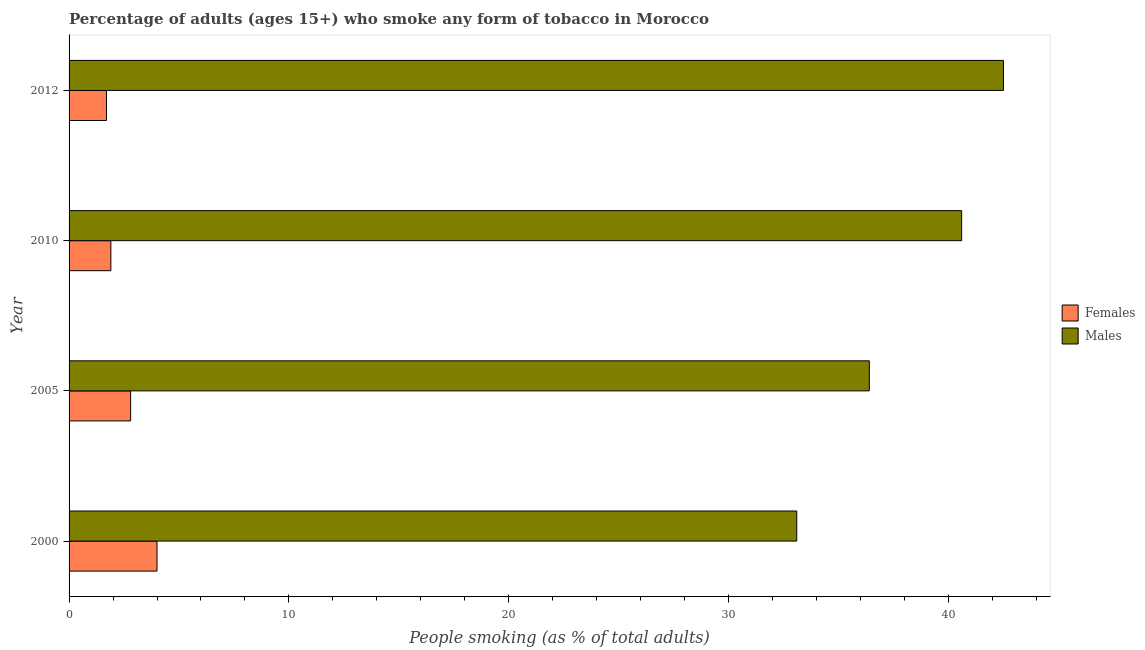How many different coloured bars are there?
Make the answer very short. 2. How many groups of bars are there?
Provide a succinct answer. 4. Are the number of bars on each tick of the Y-axis equal?
Give a very brief answer. Yes. How many bars are there on the 1st tick from the bottom?
Give a very brief answer. 2. What is the percentage of males who smoke in 2000?
Offer a terse response. 33.1. Across all years, what is the maximum percentage of males who smoke?
Provide a succinct answer. 42.5. Across all years, what is the minimum percentage of males who smoke?
Offer a terse response. 33.1. In which year was the percentage of females who smoke minimum?
Provide a succinct answer. 2012. What is the total percentage of males who smoke in the graph?
Offer a terse response. 152.6. What is the difference between the percentage of males who smoke in 2000 and the percentage of females who smoke in 2012?
Keep it short and to the point. 31.4. What is the average percentage of males who smoke per year?
Make the answer very short. 38.15. In the year 2012, what is the difference between the percentage of males who smoke and percentage of females who smoke?
Ensure brevity in your answer.  40.8. What is the ratio of the percentage of females who smoke in 2000 to that in 2012?
Make the answer very short. 2.35. Is the percentage of females who smoke in 2005 less than that in 2012?
Offer a terse response. No. Is the difference between the percentage of males who smoke in 2000 and 2005 greater than the difference between the percentage of females who smoke in 2000 and 2005?
Offer a very short reply. No. What is the difference between the highest and the second highest percentage of females who smoke?
Your response must be concise. 1.2. Is the sum of the percentage of males who smoke in 2005 and 2010 greater than the maximum percentage of females who smoke across all years?
Your answer should be compact. Yes. What does the 2nd bar from the top in 2012 represents?
Give a very brief answer. Females. What does the 2nd bar from the bottom in 2005 represents?
Keep it short and to the point. Males. Are all the bars in the graph horizontal?
Your response must be concise. Yes. What is the difference between two consecutive major ticks on the X-axis?
Keep it short and to the point. 10. Are the values on the major ticks of X-axis written in scientific E-notation?
Your answer should be very brief. No. Does the graph contain any zero values?
Provide a succinct answer. No. Does the graph contain grids?
Give a very brief answer. No. Where does the legend appear in the graph?
Make the answer very short. Center right. How are the legend labels stacked?
Ensure brevity in your answer.  Vertical. What is the title of the graph?
Provide a short and direct response. Percentage of adults (ages 15+) who smoke any form of tobacco in Morocco. What is the label or title of the X-axis?
Offer a terse response. People smoking (as % of total adults). What is the People smoking (as % of total adults) of Females in 2000?
Your answer should be compact. 4. What is the People smoking (as % of total adults) in Males in 2000?
Give a very brief answer. 33.1. What is the People smoking (as % of total adults) in Females in 2005?
Make the answer very short. 2.8. What is the People smoking (as % of total adults) in Males in 2005?
Your answer should be very brief. 36.4. What is the People smoking (as % of total adults) in Females in 2010?
Keep it short and to the point. 1.9. What is the People smoking (as % of total adults) of Males in 2010?
Provide a succinct answer. 40.6. What is the People smoking (as % of total adults) in Males in 2012?
Your answer should be very brief. 42.5. Across all years, what is the maximum People smoking (as % of total adults) in Females?
Ensure brevity in your answer.  4. Across all years, what is the maximum People smoking (as % of total adults) of Males?
Offer a terse response. 42.5. Across all years, what is the minimum People smoking (as % of total adults) of Females?
Offer a very short reply. 1.7. Across all years, what is the minimum People smoking (as % of total adults) of Males?
Offer a very short reply. 33.1. What is the total People smoking (as % of total adults) of Males in the graph?
Ensure brevity in your answer.  152.6. What is the difference between the People smoking (as % of total adults) in Females in 2000 and that in 2012?
Offer a terse response. 2.3. What is the difference between the People smoking (as % of total adults) in Males in 2000 and that in 2012?
Offer a terse response. -9.4. What is the difference between the People smoking (as % of total adults) in Females in 2005 and that in 2010?
Your answer should be compact. 0.9. What is the difference between the People smoking (as % of total adults) in Males in 2005 and that in 2010?
Keep it short and to the point. -4.2. What is the difference between the People smoking (as % of total adults) in Females in 2010 and that in 2012?
Offer a terse response. 0.2. What is the difference between the People smoking (as % of total adults) of Females in 2000 and the People smoking (as % of total adults) of Males in 2005?
Your answer should be very brief. -32.4. What is the difference between the People smoking (as % of total adults) of Females in 2000 and the People smoking (as % of total adults) of Males in 2010?
Offer a terse response. -36.6. What is the difference between the People smoking (as % of total adults) of Females in 2000 and the People smoking (as % of total adults) of Males in 2012?
Offer a terse response. -38.5. What is the difference between the People smoking (as % of total adults) of Females in 2005 and the People smoking (as % of total adults) of Males in 2010?
Your answer should be compact. -37.8. What is the difference between the People smoking (as % of total adults) in Females in 2005 and the People smoking (as % of total adults) in Males in 2012?
Provide a succinct answer. -39.7. What is the difference between the People smoking (as % of total adults) of Females in 2010 and the People smoking (as % of total adults) of Males in 2012?
Your answer should be very brief. -40.6. What is the average People smoking (as % of total adults) of Males per year?
Provide a short and direct response. 38.15. In the year 2000, what is the difference between the People smoking (as % of total adults) of Females and People smoking (as % of total adults) of Males?
Offer a very short reply. -29.1. In the year 2005, what is the difference between the People smoking (as % of total adults) of Females and People smoking (as % of total adults) of Males?
Provide a succinct answer. -33.6. In the year 2010, what is the difference between the People smoking (as % of total adults) in Females and People smoking (as % of total adults) in Males?
Your response must be concise. -38.7. In the year 2012, what is the difference between the People smoking (as % of total adults) of Females and People smoking (as % of total adults) of Males?
Offer a terse response. -40.8. What is the ratio of the People smoking (as % of total adults) in Females in 2000 to that in 2005?
Your answer should be very brief. 1.43. What is the ratio of the People smoking (as % of total adults) of Males in 2000 to that in 2005?
Offer a terse response. 0.91. What is the ratio of the People smoking (as % of total adults) of Females in 2000 to that in 2010?
Your answer should be compact. 2.11. What is the ratio of the People smoking (as % of total adults) of Males in 2000 to that in 2010?
Ensure brevity in your answer.  0.82. What is the ratio of the People smoking (as % of total adults) of Females in 2000 to that in 2012?
Keep it short and to the point. 2.35. What is the ratio of the People smoking (as % of total adults) in Males in 2000 to that in 2012?
Offer a very short reply. 0.78. What is the ratio of the People smoking (as % of total adults) of Females in 2005 to that in 2010?
Offer a very short reply. 1.47. What is the ratio of the People smoking (as % of total adults) in Males in 2005 to that in 2010?
Keep it short and to the point. 0.9. What is the ratio of the People smoking (as % of total adults) of Females in 2005 to that in 2012?
Offer a terse response. 1.65. What is the ratio of the People smoking (as % of total adults) in Males in 2005 to that in 2012?
Your answer should be compact. 0.86. What is the ratio of the People smoking (as % of total adults) in Females in 2010 to that in 2012?
Your response must be concise. 1.12. What is the ratio of the People smoking (as % of total adults) in Males in 2010 to that in 2012?
Ensure brevity in your answer.  0.96. What is the difference between the highest and the second highest People smoking (as % of total adults) of Females?
Provide a succinct answer. 1.2. What is the difference between the highest and the second highest People smoking (as % of total adults) of Males?
Ensure brevity in your answer.  1.9. 